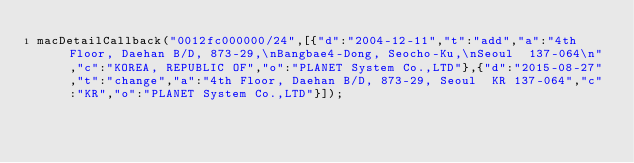Convert code to text. <code><loc_0><loc_0><loc_500><loc_500><_JavaScript_>macDetailCallback("0012fc000000/24",[{"d":"2004-12-11","t":"add","a":"4th Floor, Daehan B/D, 873-29,\nBangbae4-Dong, Seocho-Ku,\nSeoul  137-064\n","c":"KOREA, REPUBLIC OF","o":"PLANET System Co.,LTD"},{"d":"2015-08-27","t":"change","a":"4th Floor, Daehan B/D, 873-29, Seoul  KR 137-064","c":"KR","o":"PLANET System Co.,LTD"}]);
</code> 